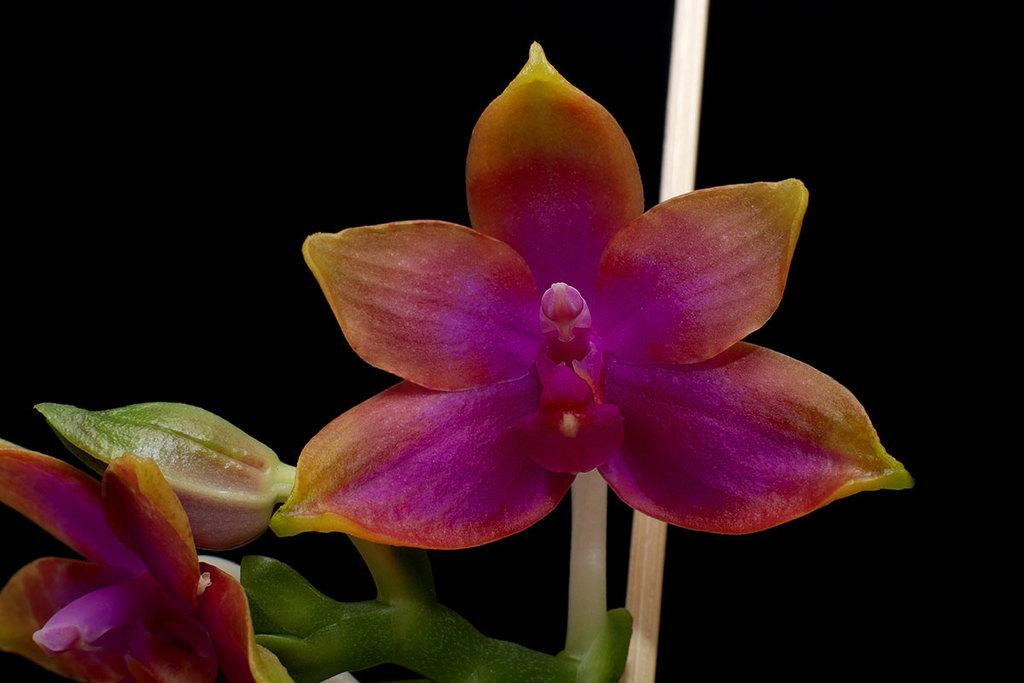How many flowers can be seen in the image? There are 2 flowers in the image. What colors are present on the flowers? The flowers have yellow, orange, and pink colors. Is there any indication of a flower in its early stage of growth in the image? Yes, there is a flower bud in the image. Do the flowers have any visible support structures? Yes, the flowers have stems. What is the color of the background in the image? The background of the image is dark. What type of meat can be seen hanging from the flower stems in the image? There is no meat present in the image; it features flowers with stems and a dark background. 